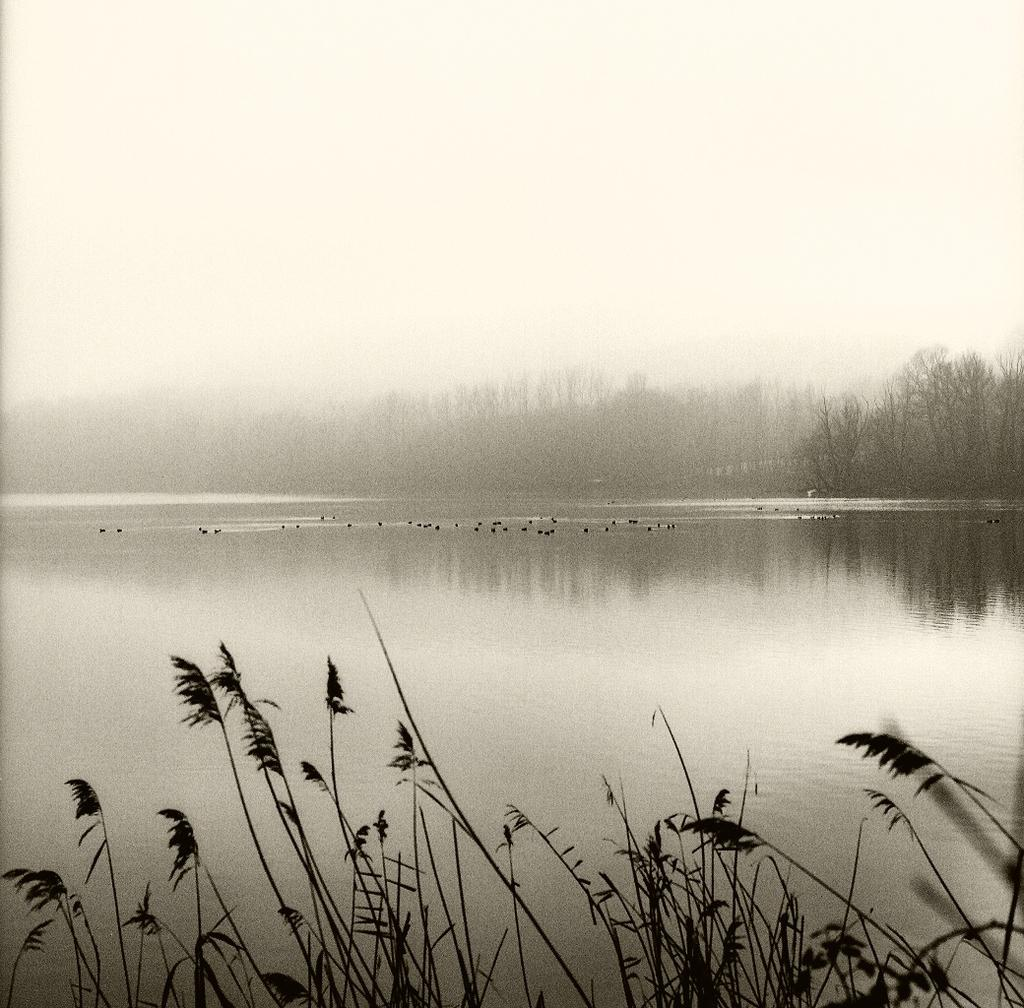What type of natural feature is present in the image? There is a river in the image. What can be seen in the river? There are swimming in the river. What type of vegetation is visible in the front of the image? There is grass in the front of the image. What is visible in the background of the image? There are trees in the background of the image. How are the trees in the background of the image affected by the weather? The trees are covered with fog in the background of the image. What type of juice is being squeezed out of the family in the image? There is no family or juice present in the image; it features a river with species swimming in it, grass, trees, and fog. 